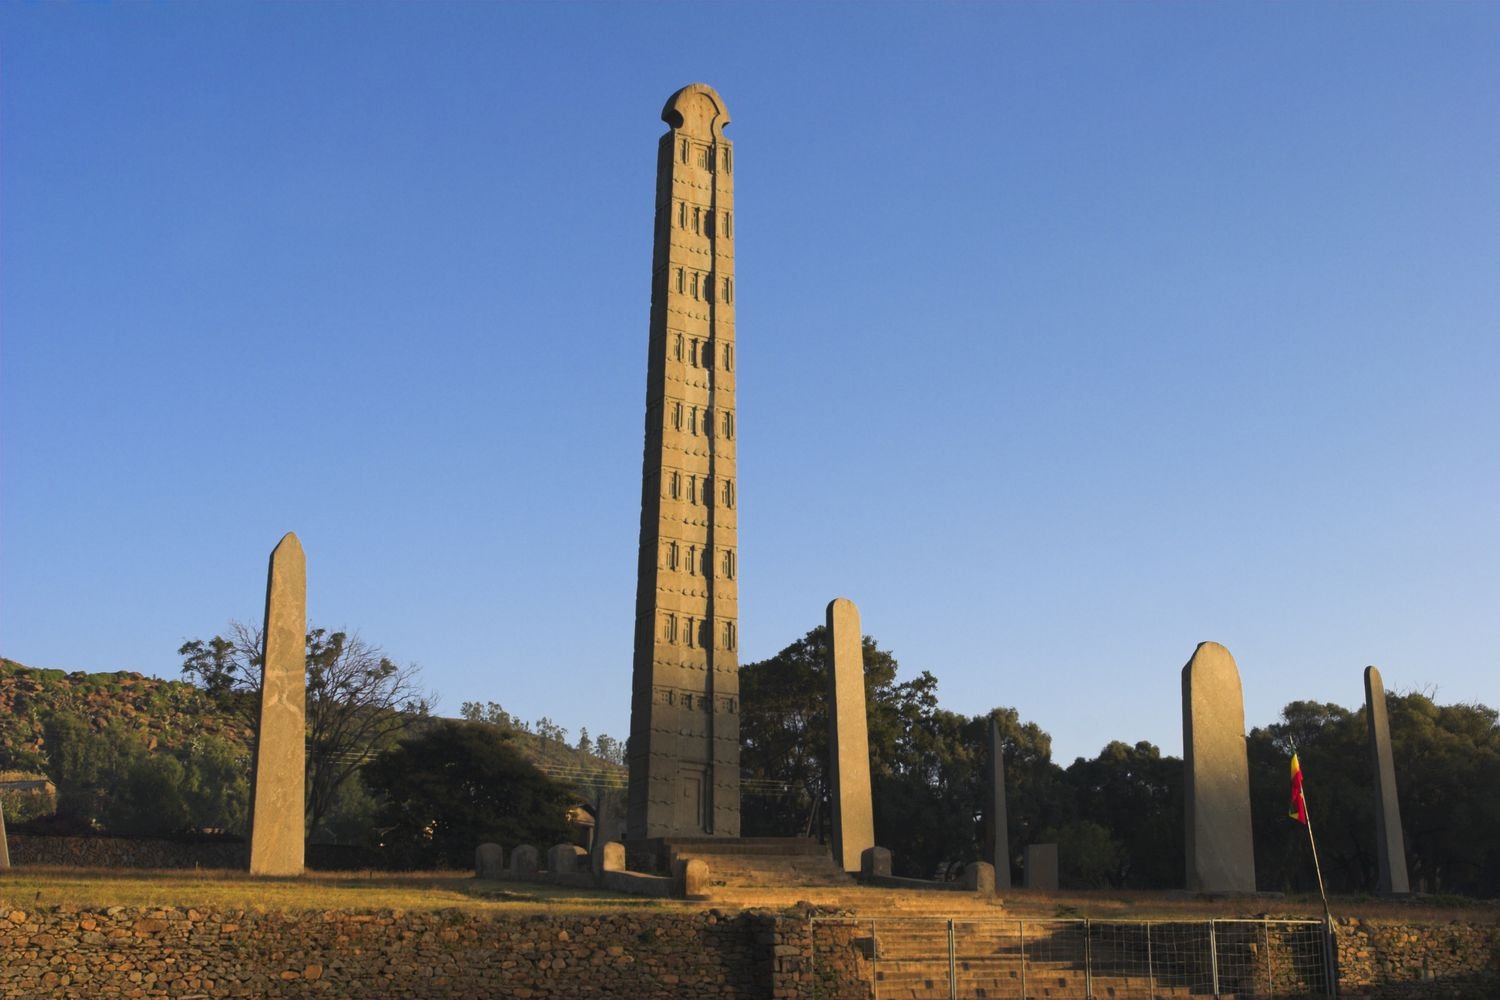Could you describe a day in the life of an Aksumite overseeing the construction of this obelisk? Imagine an Aksumite overseer named Eddesen, tasked with the construction of the great obelisk. Eddesen would rise with the dawn, greeted by the first light illuminating the mountains and bathing the workshop in golden hues. His day would start with a ritual to invoke blessings for the project. Meeting with skilled laborers, stonemasons, and architects, he would review designs carved onto parchment made from animal hides. The air would be filled with the rhythmic sounds of chisels striking granite, a cacophony of human effort working in unison. Eddesen would walk among the workers, offering guidance and ensuring that each mark on the obelisk adhered to the plans depicting doors, windows, and intricate patterns. By midday, the sun blazing overhead, he would take a brief respite, eating barley bread and honey under the shade of olive trees. The evening would see the day’s progress reviewed and preparations made for the next sunrise. Eddesen’s role would not only require technical knowledge and leadership but also a deep sense of cultural purpose, understanding that this obelisk would stand for millennia as a testament to their civilization. Can you explain the religious importance of the obelisk? The obelisk held profound religious significance for the Aksumites. As grand grave markers, they were integral to burial practices, believed to honor the deceased and provide a connection between the earthly life and the afterlife. The false doors and window-like carvings represented portals to other realms, suggesting an eternal dwelling for the elite in the afterlife. Additionally, the obelisks imbued the landscape with sacredness, their towering presence reflecting the divine authority. They were considered symbols of divine and royal power, and rituals may have been performed around them to invoke protection and blessings from the gods. With the Kingdom of Aksum being one of the earliest to embrace Christianity, such obelisks also highlight the transition in the region's spiritual landscape, marking the interweaving of old beliefs with new Christian practices. 